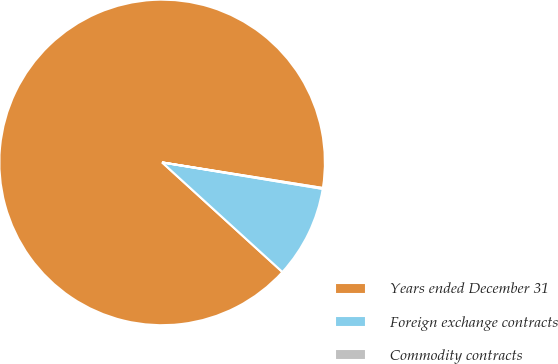Convert chart. <chart><loc_0><loc_0><loc_500><loc_500><pie_chart><fcel>Years ended December 31<fcel>Foreign exchange contracts<fcel>Commodity contracts<nl><fcel>90.75%<fcel>9.16%<fcel>0.09%<nl></chart> 